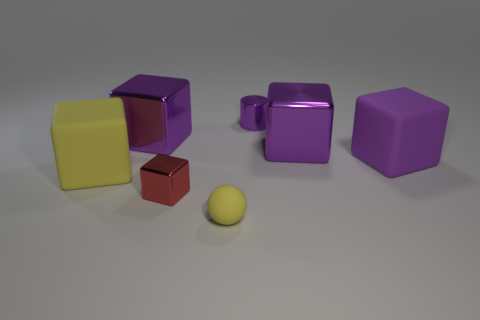How many metallic things are either small yellow things or red cylinders?
Provide a succinct answer. 0. Are there any other things that are the same material as the yellow cube?
Provide a short and direct response. Yes. What size is the matte thing that is behind the big rubber object that is in front of the rubber object on the right side of the metal cylinder?
Provide a short and direct response. Large. There is a object that is behind the yellow matte block and to the left of the tiny block; what is its size?
Your response must be concise. Large. Do the small metallic object that is behind the large yellow thing and the big rubber thing that is to the right of the small metallic cube have the same color?
Ensure brevity in your answer.  Yes. There is a tiny rubber ball; how many tiny red objects are left of it?
Offer a very short reply. 1. There is a purple object left of the metallic thing in front of the purple matte object; are there any balls that are behind it?
Provide a succinct answer. No. How many blue metallic things have the same size as the red metal block?
Your answer should be very brief. 0. There is a object that is to the left of the purple block that is on the left side of the red block; what is it made of?
Offer a very short reply. Rubber. What shape is the metal object behind the large purple cube on the left side of the yellow thing in front of the red block?
Provide a succinct answer. Cylinder. 